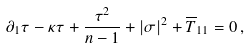Convert formula to latex. <formula><loc_0><loc_0><loc_500><loc_500>\partial _ { 1 } \tau - \kappa \tau + \frac { \tau ^ { 2 } } { n - 1 } + | \sigma | ^ { 2 } + \overline { T } _ { 1 1 } = 0 \, ,</formula> 